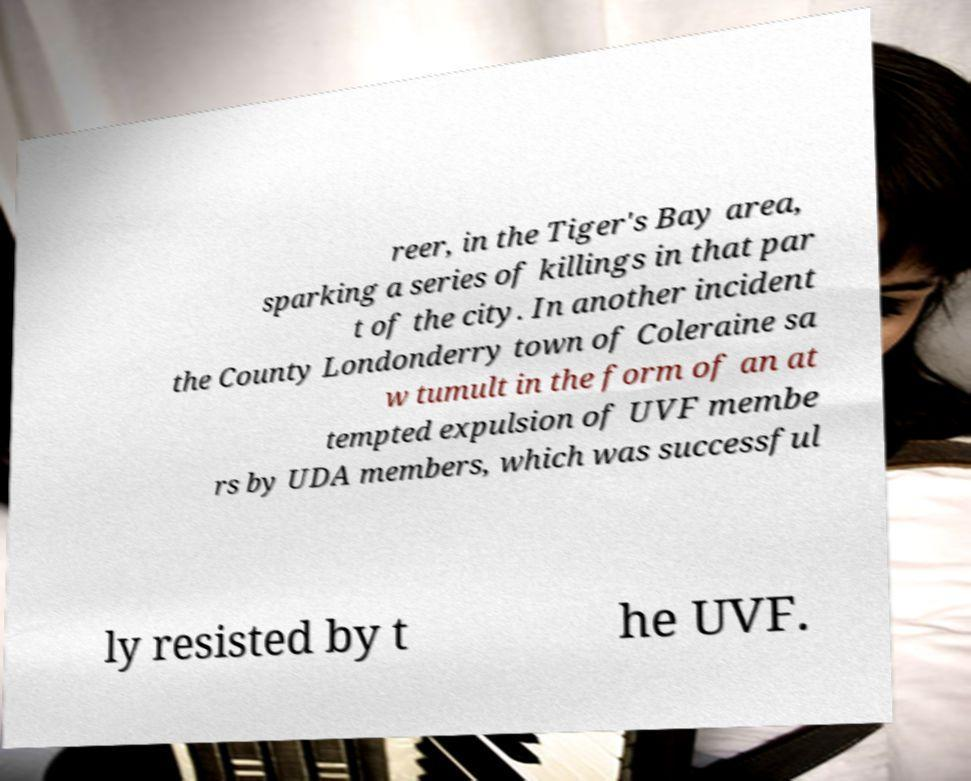I need the written content from this picture converted into text. Can you do that? reer, in the Tiger's Bay area, sparking a series of killings in that par t of the city. In another incident the County Londonderry town of Coleraine sa w tumult in the form of an at tempted expulsion of UVF membe rs by UDA members, which was successful ly resisted by t he UVF. 